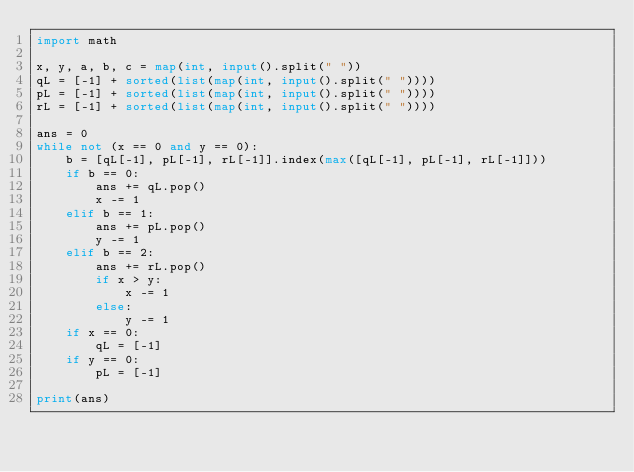Convert code to text. <code><loc_0><loc_0><loc_500><loc_500><_Python_>import math

x, y, a, b, c = map(int, input().split(" "))
qL = [-1] + sorted(list(map(int, input().split(" "))))
pL = [-1] + sorted(list(map(int, input().split(" "))))
rL = [-1] + sorted(list(map(int, input().split(" "))))

ans = 0
while not (x == 0 and y == 0):
    b = [qL[-1], pL[-1], rL[-1]].index(max([qL[-1], pL[-1], rL[-1]]))
    if b == 0:
        ans += qL.pop()
        x -= 1
    elif b == 1:
        ans += pL.pop()
        y -= 1
    elif b == 2:
        ans += rL.pop()
        if x > y:
            x -= 1
        else:
            y -= 1
    if x == 0:
        qL = [-1]
    if y == 0:
        pL = [-1]

print(ans)</code> 